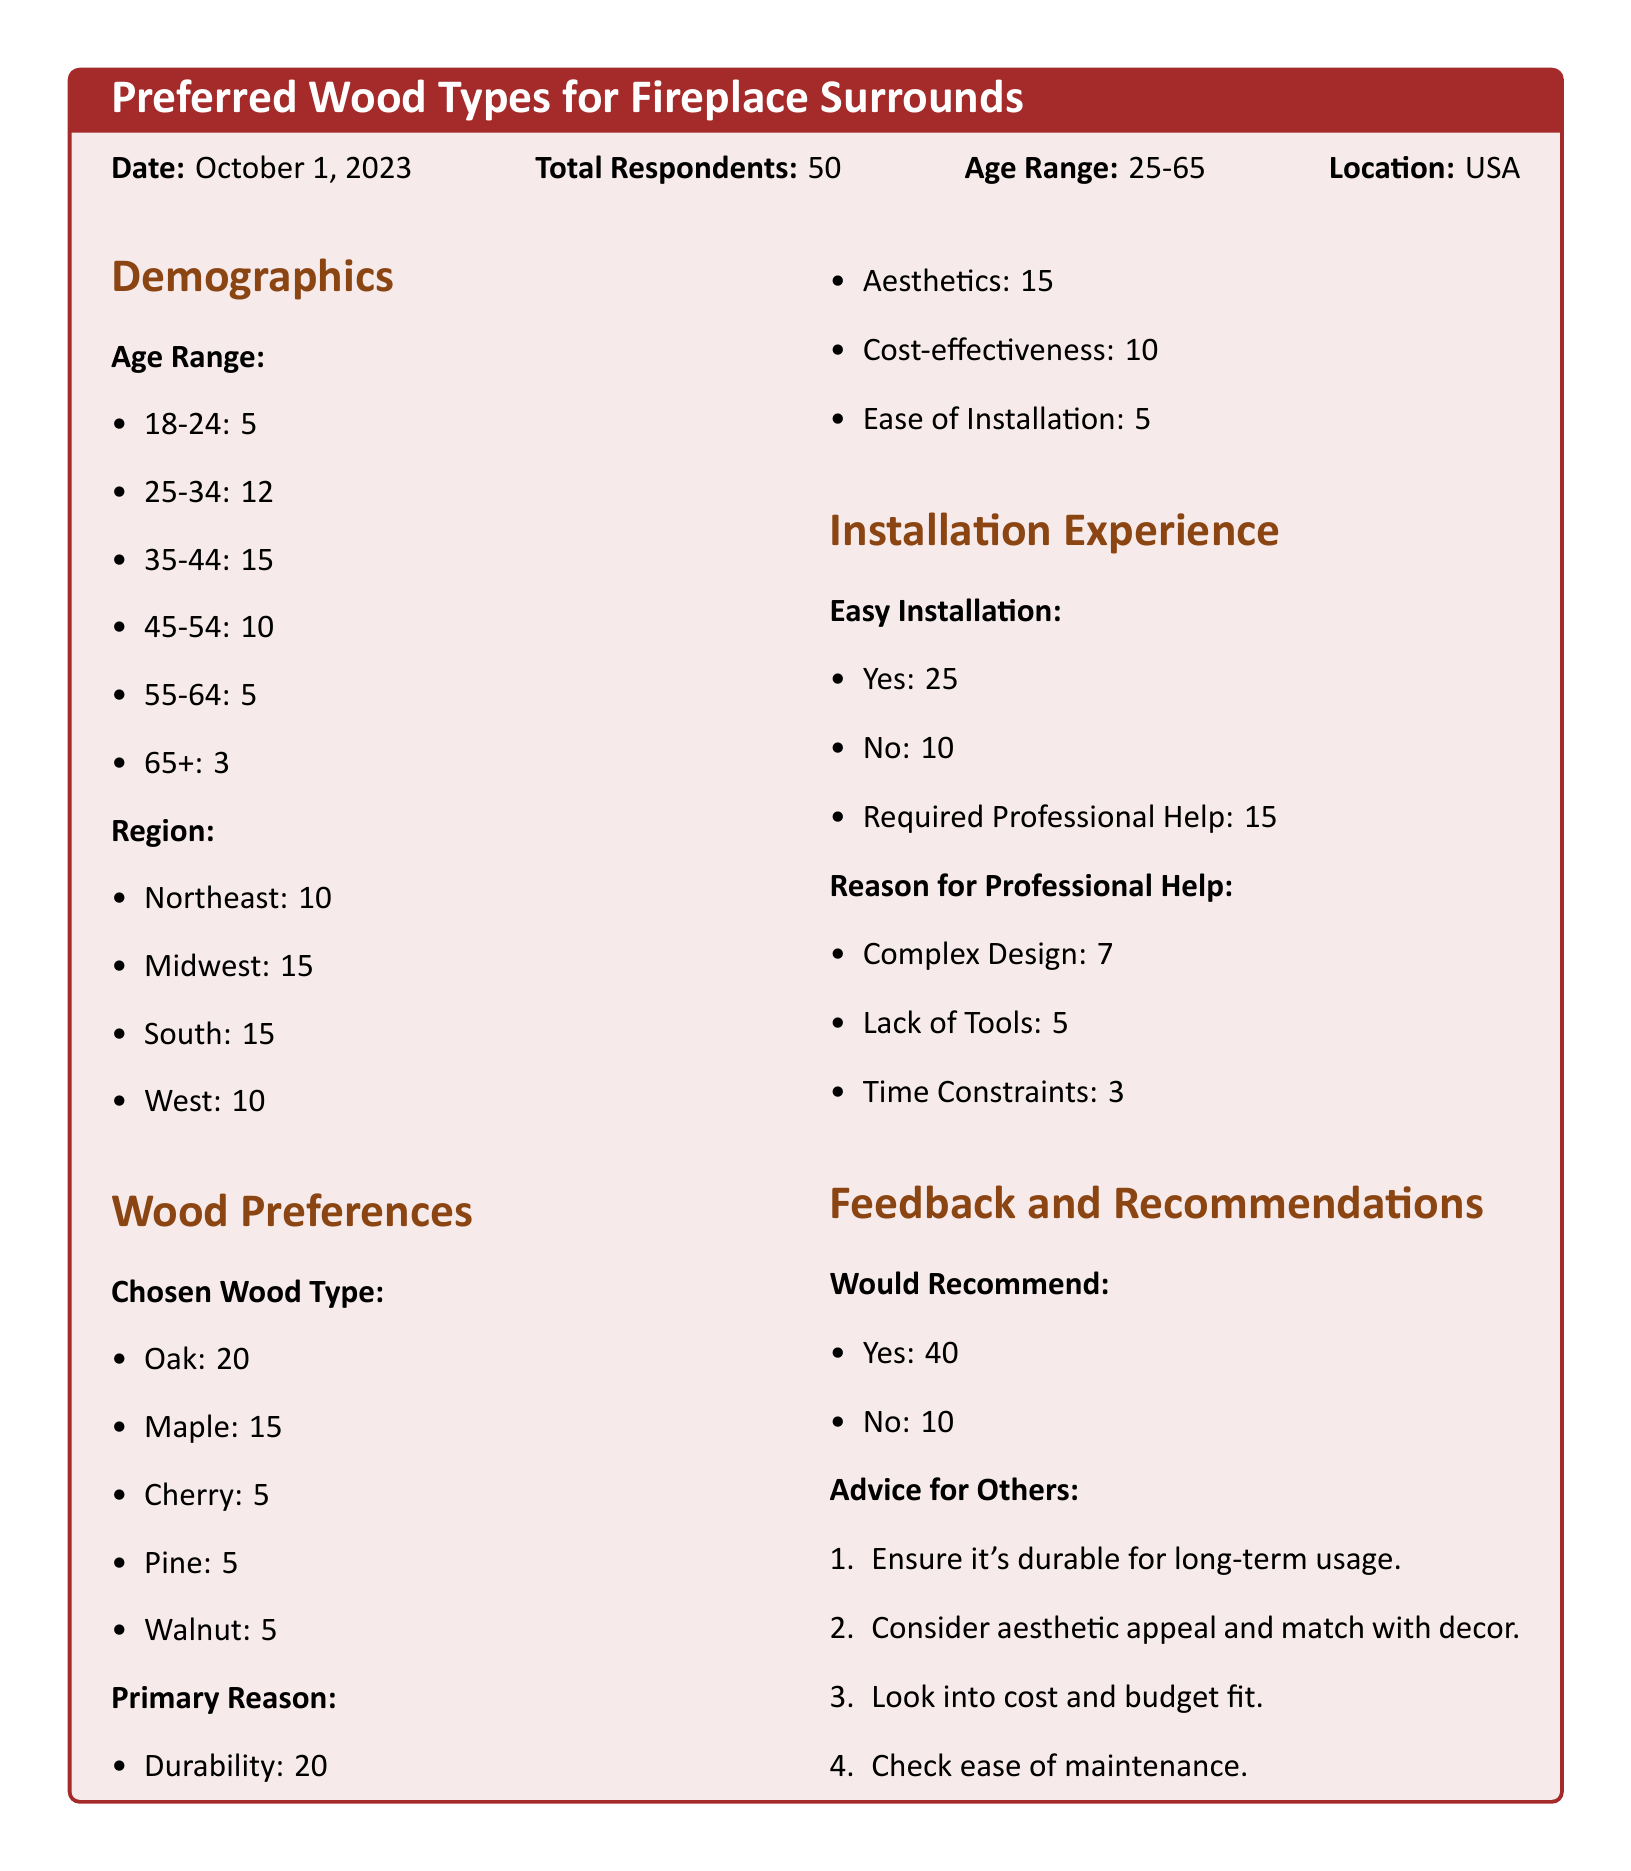What is the total number of respondents? The total number of respondents is explicitly stated at the beginning of the document as 50.
Answer: 50 What wood type had the highest preference? The document lists wood types and their corresponding counts, with Oak being the most preferred at 20.
Answer: Oak How many respondents chose Cherry? The document specifies that 5 respondents chose Cherry as their preferred wood type.
Answer: 5 What is the most common reason for choosing wood type? Among the reasons listed, Durability has the highest count of 20 respondents selecting it.
Answer: Durability What percentage of respondents found installation easy? The document indicates that 25 out of 50 respondents (50%) answered Yes to finding installation easy.
Answer: 50% What advice was given for purchasing wood? The document includes a list of advice items, with "Ensure it's durable for long-term usage" being one of them.
Answer: Ensure it's durable for long-term usage How many respondents would recommend their chosen wood type? The survey results show that 40 respondents would recommend their chosen wood type to others.
Answer: 40 What region had the lowest number of respondents? The regions are listed with corresponding counts, and the West has the lowest number at 10 respondents.
Answer: West How many respondents required professional help for installation? The document states that 15 respondents required professional help for installation tasks.
Answer: 15 